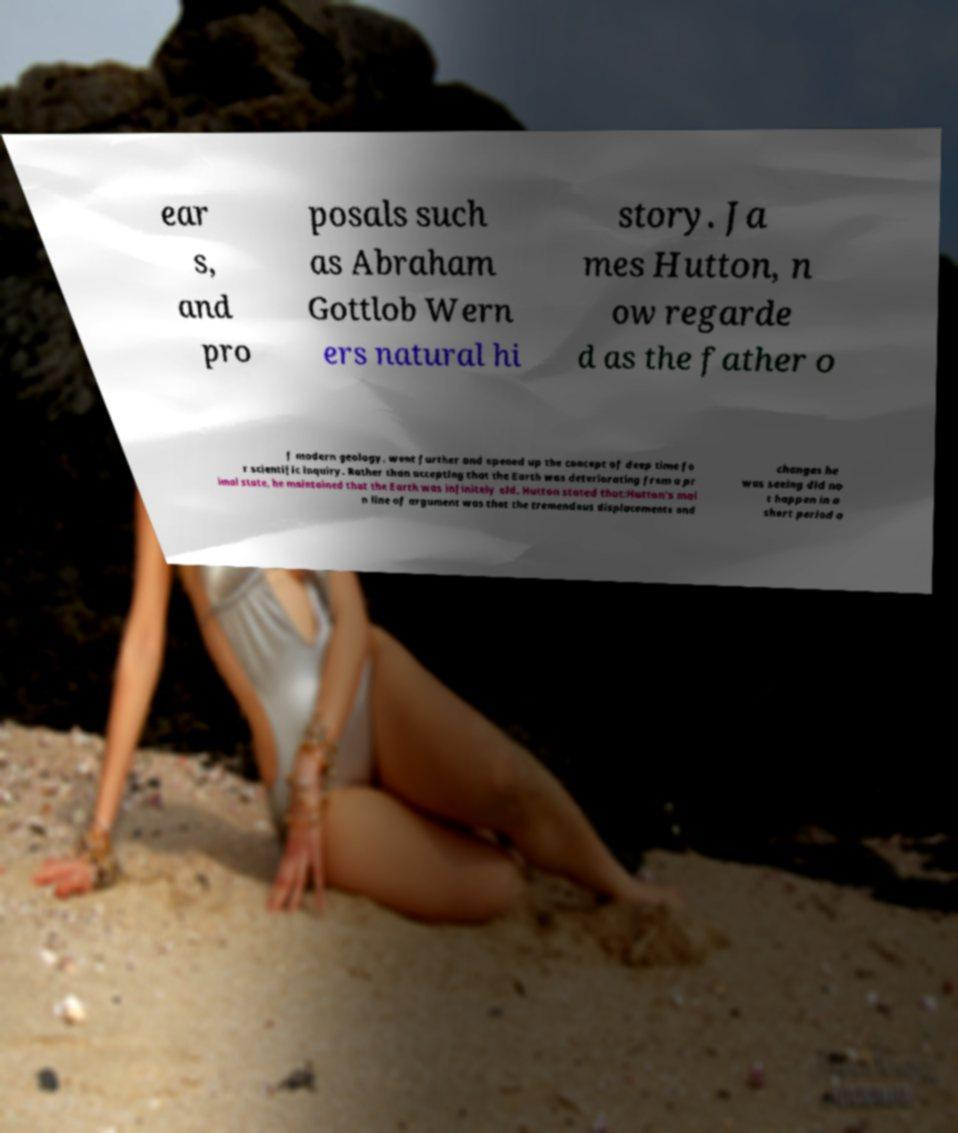I need the written content from this picture converted into text. Can you do that? ear s, and pro posals such as Abraham Gottlob Wern ers natural hi story. Ja mes Hutton, n ow regarde d as the father o f modern geology, went further and opened up the concept of deep time fo r scientific inquiry. Rather than accepting that the Earth was deteriorating from a pr imal state, he maintained that the Earth was infinitely old. Hutton stated that:Hutton's mai n line of argument was that the tremendous displacements and changes he was seeing did no t happen in a short period o 